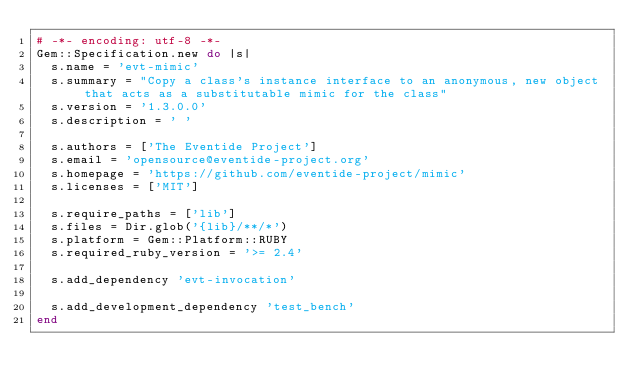<code> <loc_0><loc_0><loc_500><loc_500><_Ruby_># -*- encoding: utf-8 -*-
Gem::Specification.new do |s|
  s.name = 'evt-mimic'
  s.summary = "Copy a class's instance interface to an anonymous, new object that acts as a substitutable mimic for the class"
  s.version = '1.3.0.0'
  s.description = ' '

  s.authors = ['The Eventide Project']
  s.email = 'opensource@eventide-project.org'
  s.homepage = 'https://github.com/eventide-project/mimic'
  s.licenses = ['MIT']

  s.require_paths = ['lib']
  s.files = Dir.glob('{lib}/**/*')
  s.platform = Gem::Platform::RUBY
  s.required_ruby_version = '>= 2.4'

  s.add_dependency 'evt-invocation'

  s.add_development_dependency 'test_bench'
end
</code> 